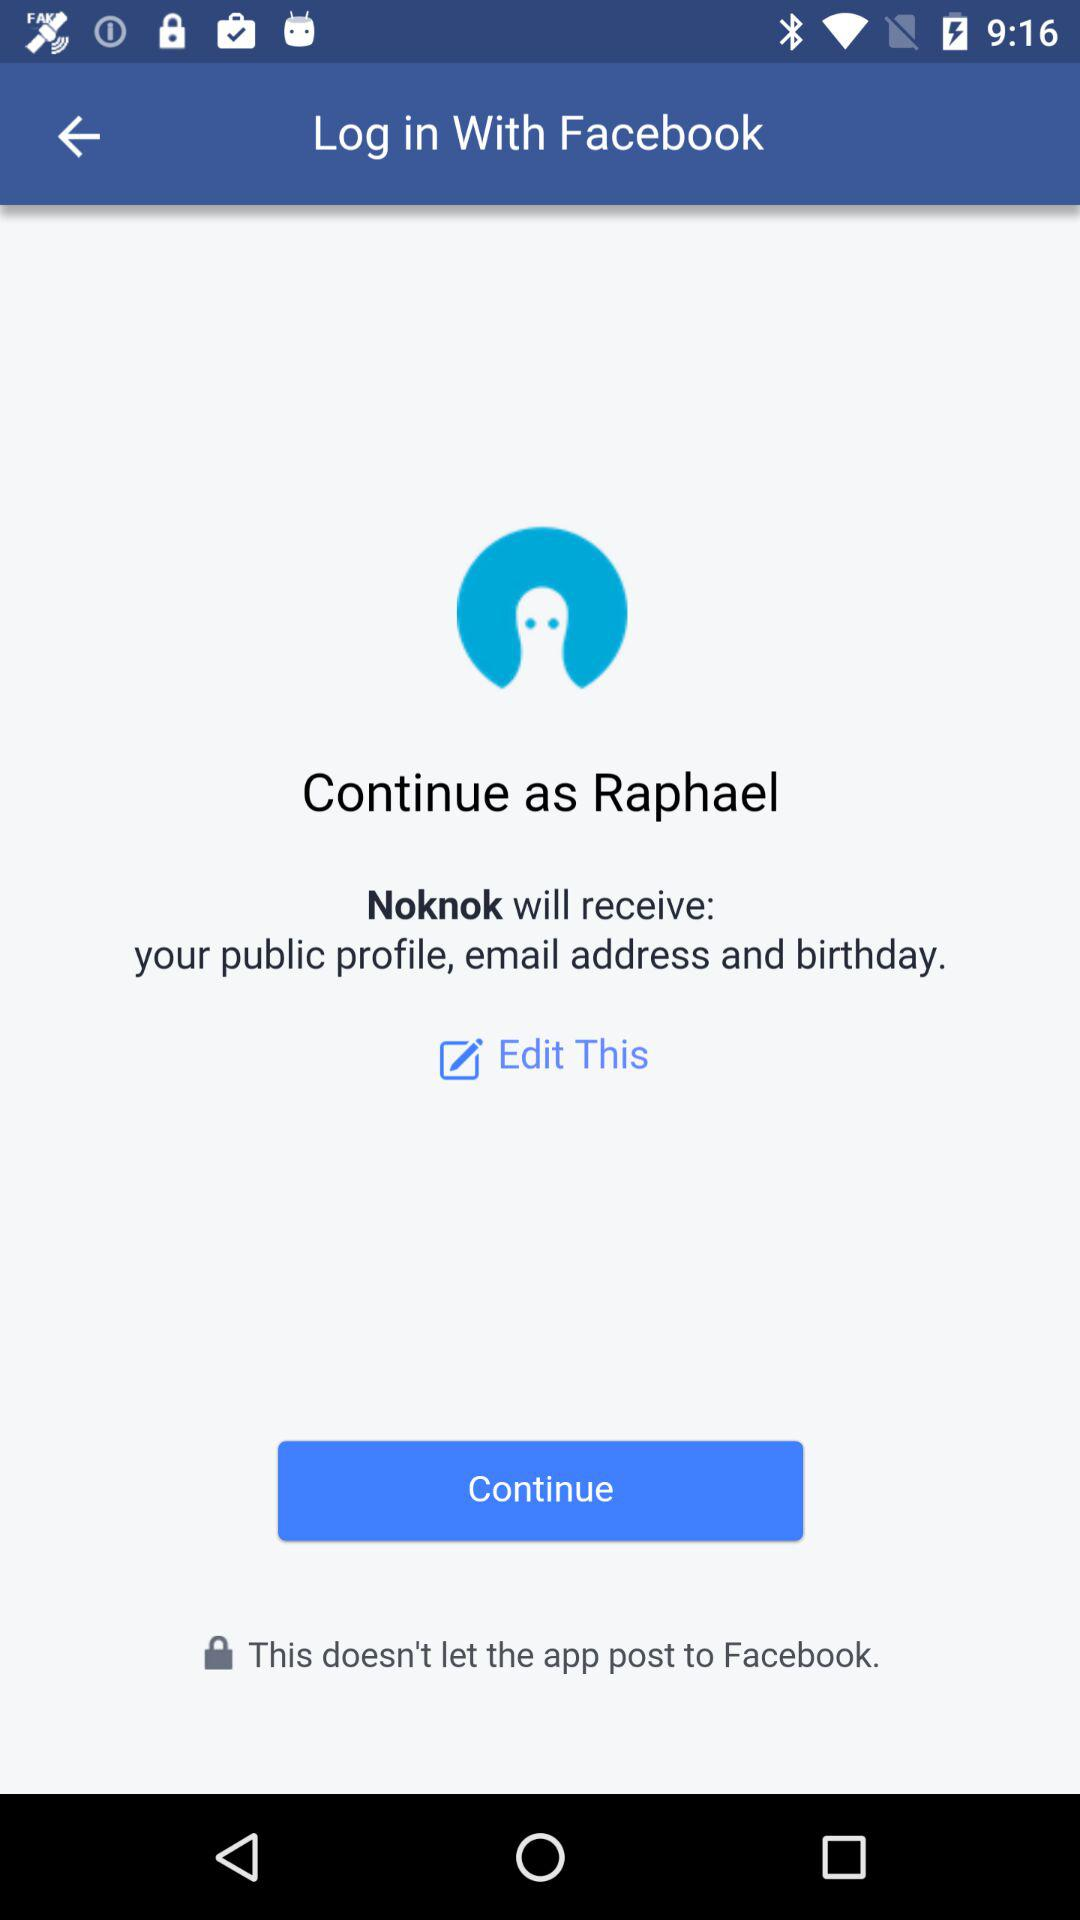What's the user name? The user name is Raphael. 